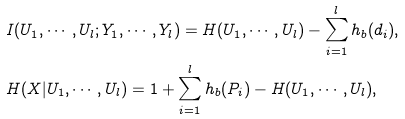Convert formula to latex. <formula><loc_0><loc_0><loc_500><loc_500>& I ( { U } _ { 1 } , \cdots , { U } _ { l } ; { Y } _ { 1 } , \cdots , { Y } _ { l } ) = H ( U _ { 1 } , \cdots , U _ { l } ) - \sum _ { i = 1 } ^ { l } h _ { b } ( d _ { i } ) , \\ & H ( { X } | { U } _ { 1 } , \cdots , { U } _ { l } ) = 1 + \sum _ { i = 1 } ^ { l } h _ { b } ( P _ { i } ) - H ( U _ { 1 } , \cdots , U _ { l } ) ,</formula> 